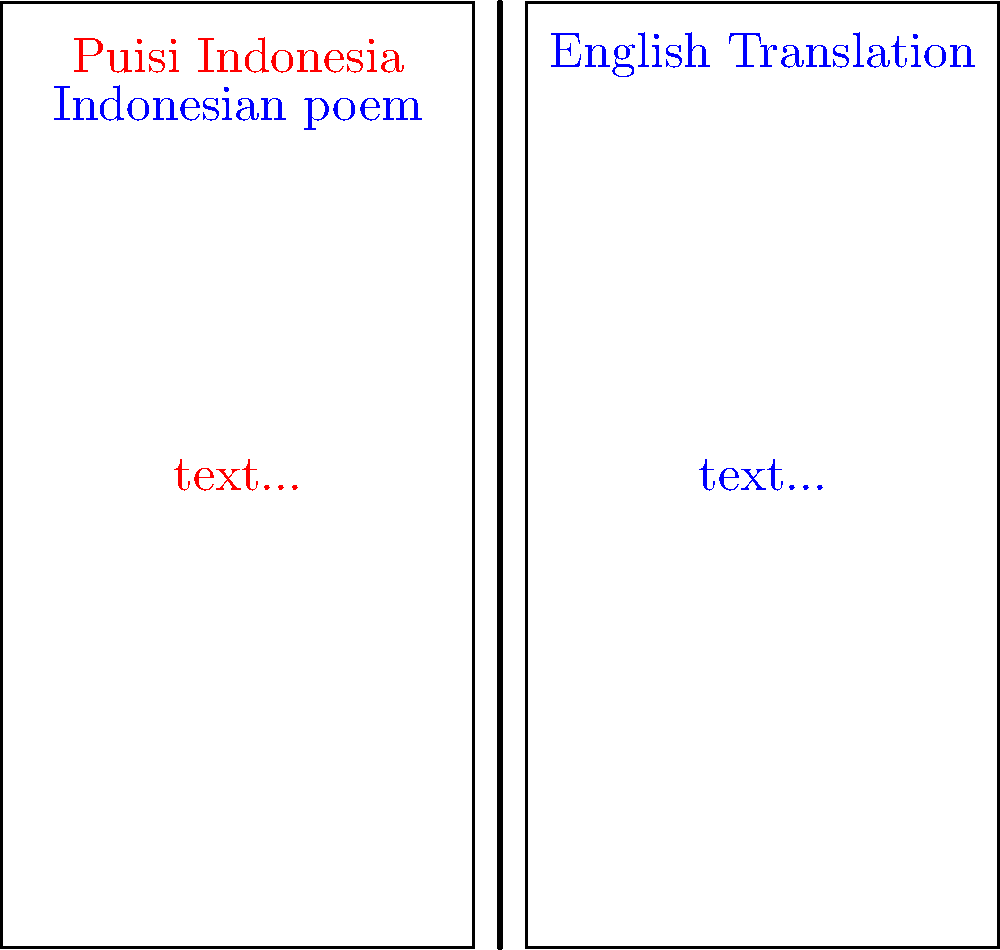In the layout of this bilingual Indonesian-English poetry collection, what feature distinguishes the Indonesian text from its English translation? To answer this question, we need to analyze the visual elements of the given layout:

1. The image shows a spread of two pages in a book.
2. The left page contains text in red, while the right page contains text in blue.
3. The left page is labeled "Puisi Indonesia" (in red) and "Indonesian poem" (in blue).
4. The right page is labeled "English Translation" (in blue).
5. The color coding is consistent: red for Indonesian and blue for English.

Based on these observations, we can conclude that the distinguishing feature between the Indonesian text and its English translation is the color of the text. Indonesian text is presented in red, while the English translation is in blue.

This color-coding system serves several purposes:
1. It visually separates the two languages, making it easier for readers to distinguish between them.
2. It allows readers to quickly locate either the original Indonesian text or its English translation.
3. It adds an aesthetic element to the book design, potentially making it more visually appealing to readers.
Answer: Color (red for Indonesian, blue for English) 